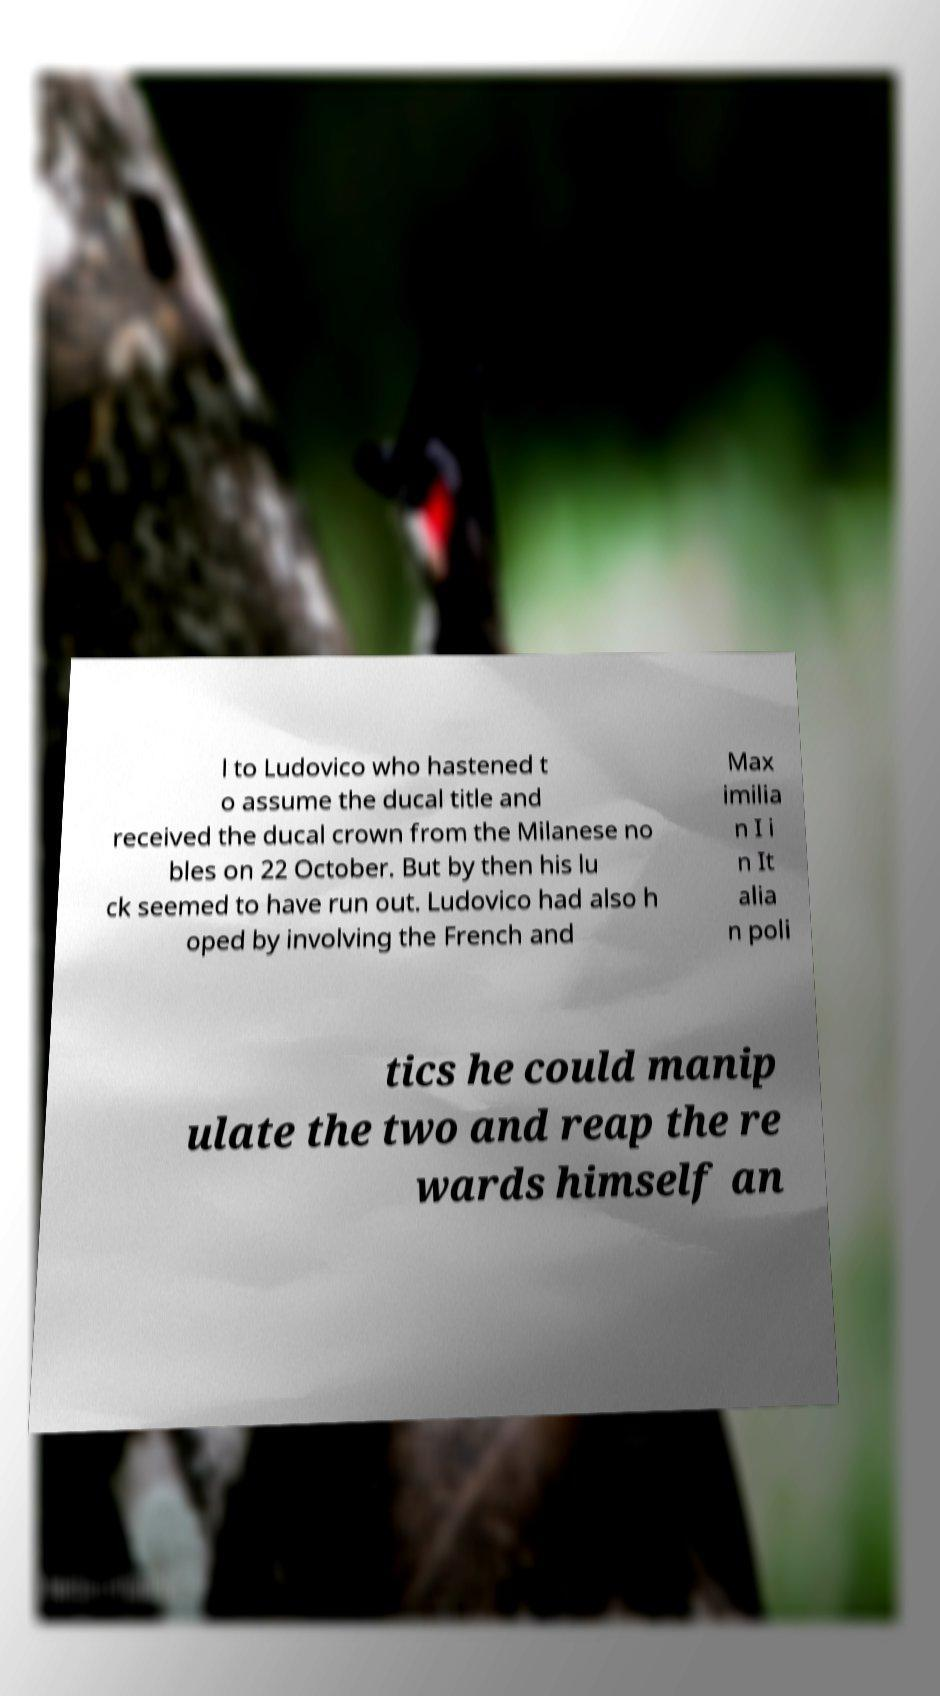There's text embedded in this image that I need extracted. Can you transcribe it verbatim? l to Ludovico who hastened t o assume the ducal title and received the ducal crown from the Milanese no bles on 22 October. But by then his lu ck seemed to have run out. Ludovico had also h oped by involving the French and Max imilia n I i n It alia n poli tics he could manip ulate the two and reap the re wards himself an 